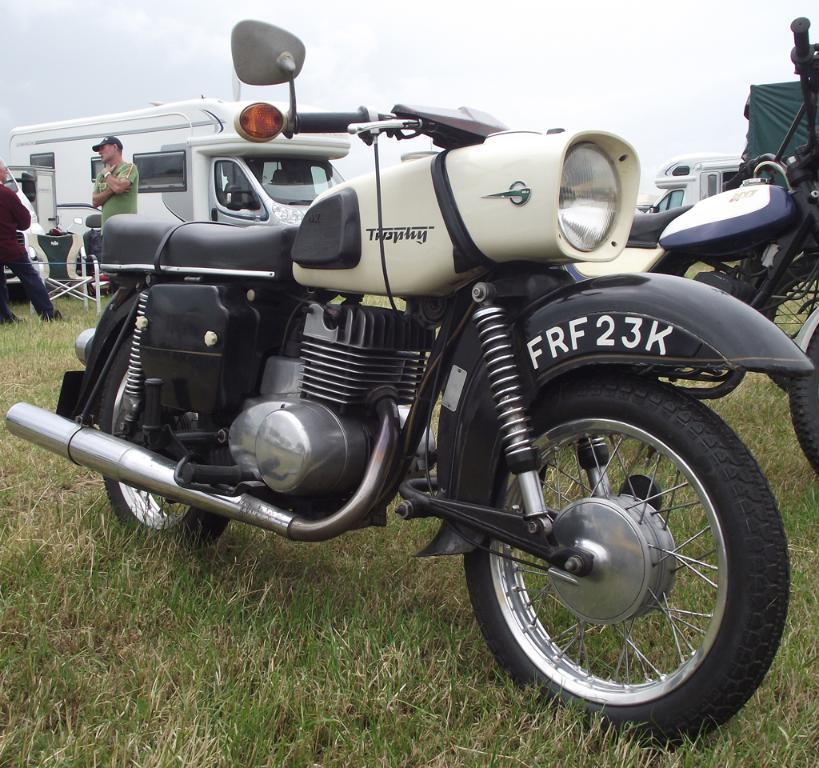What is the main subject in the center of the image? There is a bike in the center of the image. Where is the bike located? The bike is on the grass. What can be seen in the background of the image? There are vehicles, another bike, a chair, and the sky visible in the background of the image. What is the condition of the sky in the image? The sky is visible in the background of the image, and there are clouds present. Can you tell me how many snails are crawling on the notebook in the image? There is no notebook or snails present in the image. 